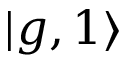<formula> <loc_0><loc_0><loc_500><loc_500>| g , 1 \rangle</formula> 